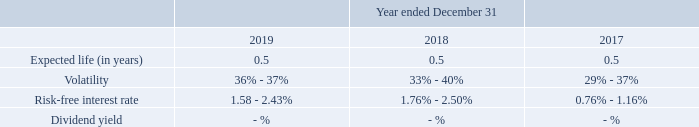The fair value of the option component of the ESPP shares was estimated at the grant date using the Black-Scholes option pricing model with the following weighted
average assumptions:
The Company issued 266 shares, 231 shares and 183 shares under the ESPP in the years ended December 31, 2019, 2018 and 2017, respectively, at a weighted average
exercise price per share of $86.51, $77.02, and $73.02, respectively. As of December 31, 2019, the Company expects to recognize $3,531 of the total unamortized compensation cost
related to employee purchases under the ESPP over a weighted average period of 0.37 years.
What is the expected life (in years) of the option component of the ESPP shares in each of the years ended December 31, 2019? 0.5, 0.5, 0.5. What is the number of shares issued in the years ended December 31, 2017 to 2019 respectively? $73.02, $77.02, $86.51. What is the total unamortized compensation cost related to employee purchases under the ESPP the company expects to recognise as of December 31, 2019? $3,531. What is the percentage change in the total unamortized compensation cost related to employee purchases under the ESPP the company expects to recognise between 2018 and 2019?
Answer scale should be: percent. (86.51 - 77.02)/77.02 
Answer: 12.32. What is the total shares issued under the ESPP between December 2017 to 2019? 266 + 231 + 183 
Answer: 680. What is the average volatility of the fair value of the option component of the ESPP shares as at December 31, 2019?
Answer scale should be: percent. (36% + 37%)/2 
Answer: 36.5. 